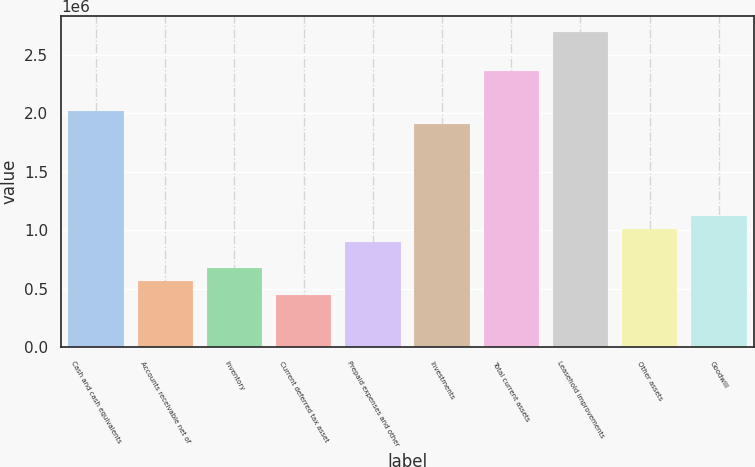Convert chart. <chart><loc_0><loc_0><loc_500><loc_500><bar_chart><fcel>Cash and cash equivalents<fcel>Accounts receivable net of<fcel>Inventory<fcel>Current deferred tax asset<fcel>Prepaid expenses and other<fcel>Investments<fcel>Total current assets<fcel>Leasehold improvements<fcel>Other assets<fcel>Goodwill<nl><fcel>2.01879e+06<fcel>560863<fcel>673011<fcel>448715<fcel>897308<fcel>1.90664e+06<fcel>2.35524e+06<fcel>2.69168e+06<fcel>1.00946e+06<fcel>1.1216e+06<nl></chart> 